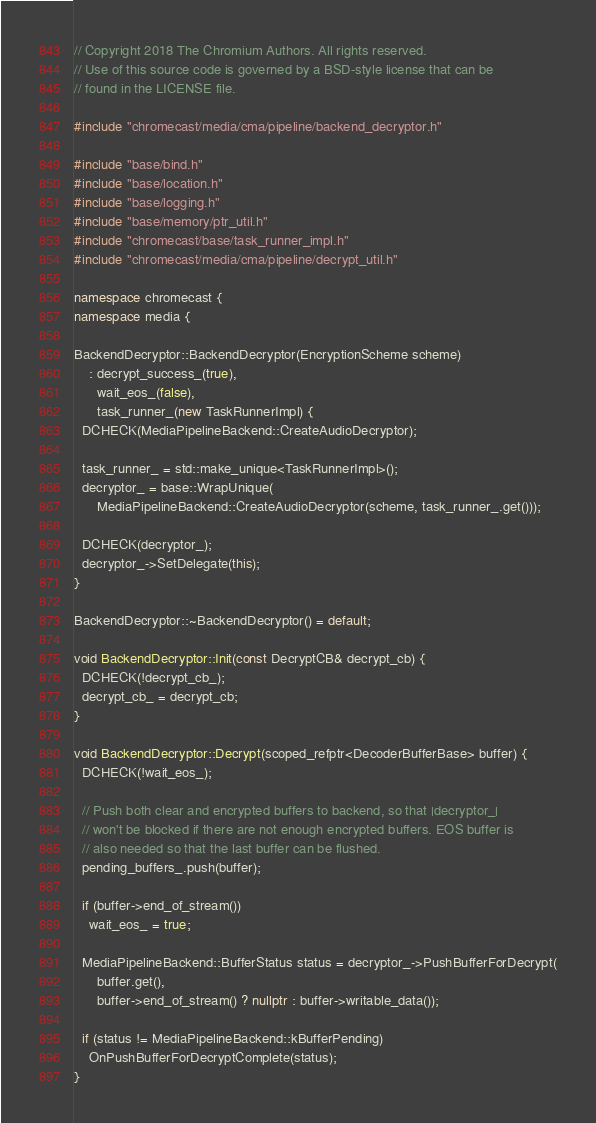<code> <loc_0><loc_0><loc_500><loc_500><_C++_>// Copyright 2018 The Chromium Authors. All rights reserved.
// Use of this source code is governed by a BSD-style license that can be
// found in the LICENSE file.

#include "chromecast/media/cma/pipeline/backend_decryptor.h"

#include "base/bind.h"
#include "base/location.h"
#include "base/logging.h"
#include "base/memory/ptr_util.h"
#include "chromecast/base/task_runner_impl.h"
#include "chromecast/media/cma/pipeline/decrypt_util.h"

namespace chromecast {
namespace media {

BackendDecryptor::BackendDecryptor(EncryptionScheme scheme)
    : decrypt_success_(true),
      wait_eos_(false),
      task_runner_(new TaskRunnerImpl) {
  DCHECK(MediaPipelineBackend::CreateAudioDecryptor);

  task_runner_ = std::make_unique<TaskRunnerImpl>();
  decryptor_ = base::WrapUnique(
      MediaPipelineBackend::CreateAudioDecryptor(scheme, task_runner_.get()));

  DCHECK(decryptor_);
  decryptor_->SetDelegate(this);
}

BackendDecryptor::~BackendDecryptor() = default;

void BackendDecryptor::Init(const DecryptCB& decrypt_cb) {
  DCHECK(!decrypt_cb_);
  decrypt_cb_ = decrypt_cb;
}

void BackendDecryptor::Decrypt(scoped_refptr<DecoderBufferBase> buffer) {
  DCHECK(!wait_eos_);

  // Push both clear and encrypted buffers to backend, so that |decryptor_|
  // won't be blocked if there are not enough encrypted buffers. EOS buffer is
  // also needed so that the last buffer can be flushed.
  pending_buffers_.push(buffer);

  if (buffer->end_of_stream())
    wait_eos_ = true;

  MediaPipelineBackend::BufferStatus status = decryptor_->PushBufferForDecrypt(
      buffer.get(),
      buffer->end_of_stream() ? nullptr : buffer->writable_data());

  if (status != MediaPipelineBackend::kBufferPending)
    OnPushBufferForDecryptComplete(status);
}
</code> 